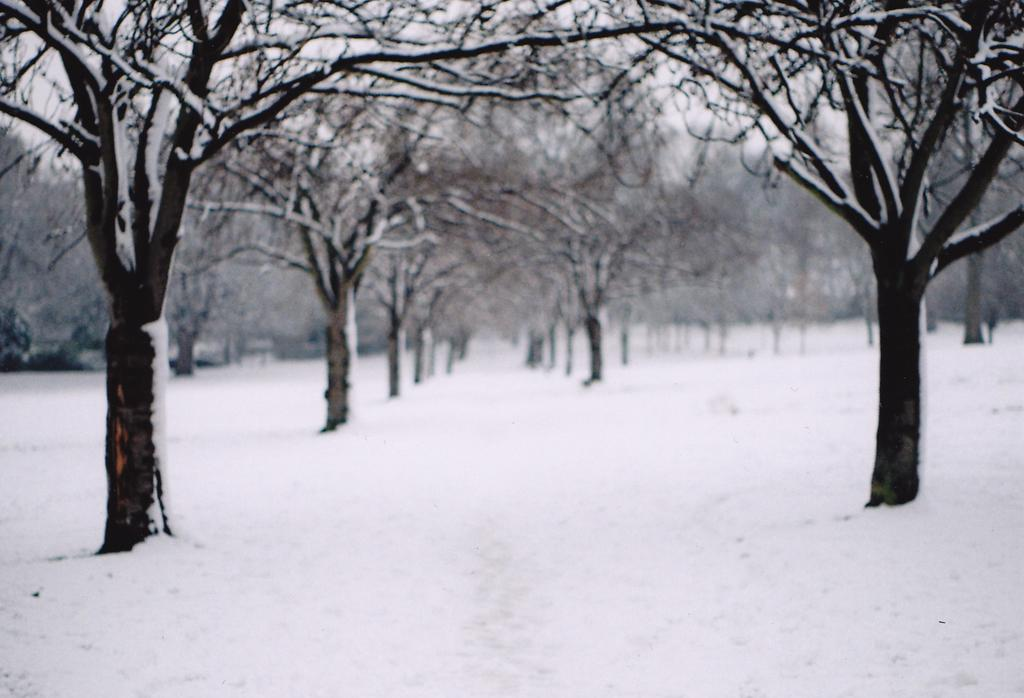What type of vegetation can be seen in the image? There are trees in the image. What is the ground covered with in the image? The ground is covered with snow, depicted in white color. What is visible in the sky in the image? The sky is visible in the image, also depicted in white color. How many pets are visible in the image? There are no pets present in the image. What type of rail can be seen in the image? There is no rail present in the image. 